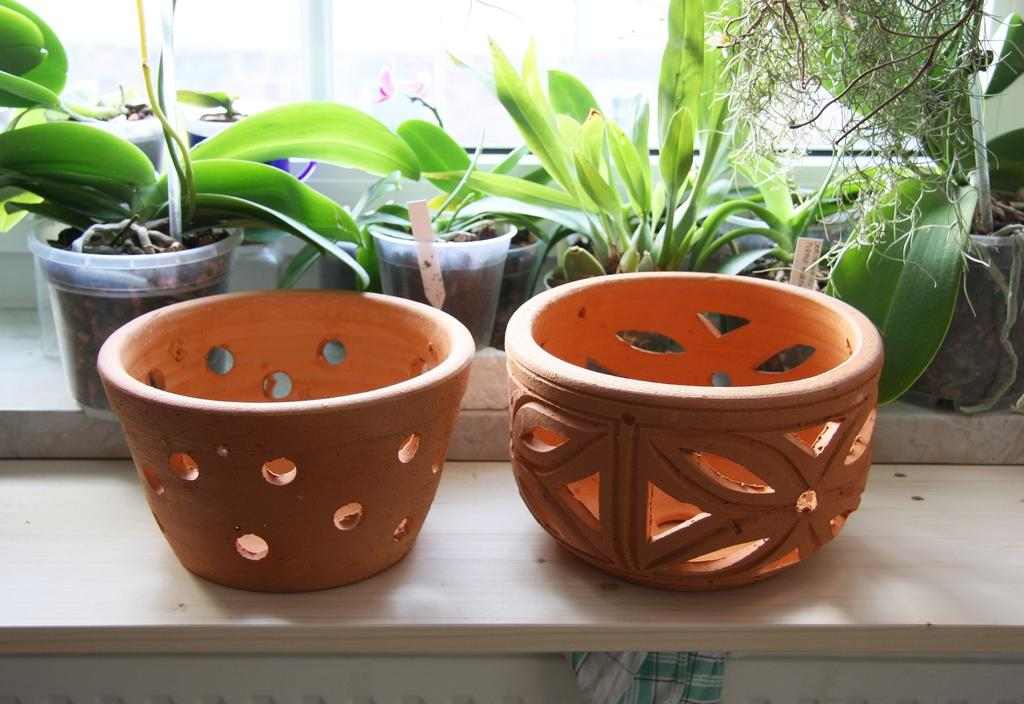Where was the image taken? The image is taken indoors. What can be seen in the background of the image? There is a window in the background of the image. What is located in the middle of the image? There are plants in pots in the middle of the image. Are there any empty pots visible in the image? Yes, there are two empty pots on a shelf. What type of yoke is being used to carry the plants in the image? There is no yoke present in the image; the plants are in pots on a surface. 